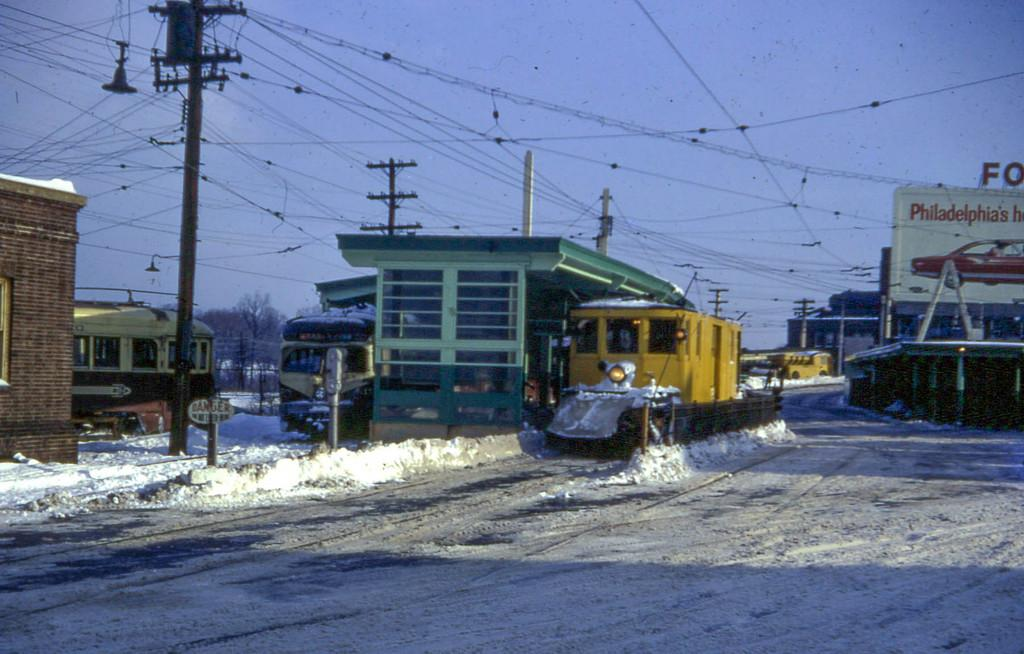What type of vehicles are present in the image? There are trains in the image. What else can be seen in the image besides the trains? Electrical poles and wires are visible in the image. What is located on the right side of the image? There is a hoarding on the right side of the image. What is the ground covered with in the image? The ground is covered with snow in the image. What is visible at the top of the image? The sky is visible at the top of the image. Where is the twig located in the image? There is no twig present in the image. What type of service does the porter provide in the image? There is no porter present in the image. 